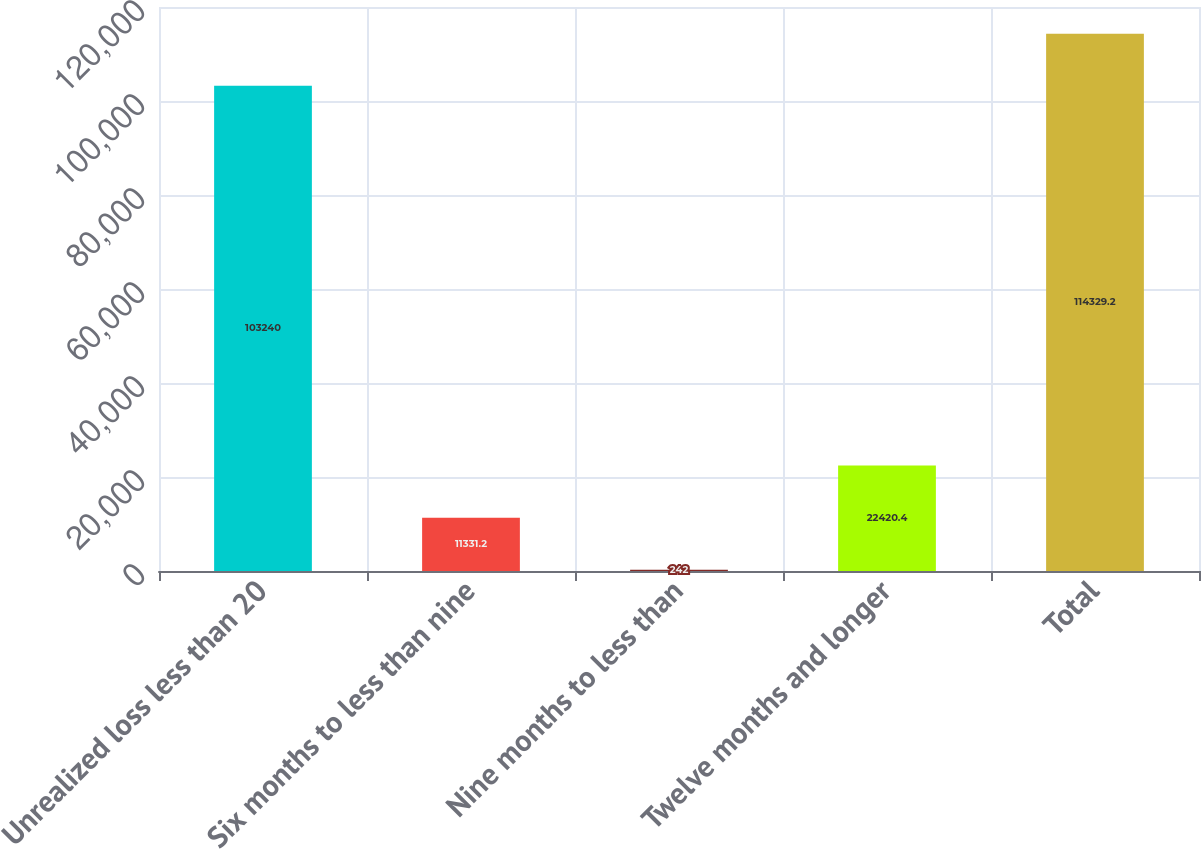Convert chart. <chart><loc_0><loc_0><loc_500><loc_500><bar_chart><fcel>Unrealized loss less than 20<fcel>Six months to less than nine<fcel>Nine months to less than<fcel>Twelve months and longer<fcel>Total<nl><fcel>103240<fcel>11331.2<fcel>242<fcel>22420.4<fcel>114329<nl></chart> 